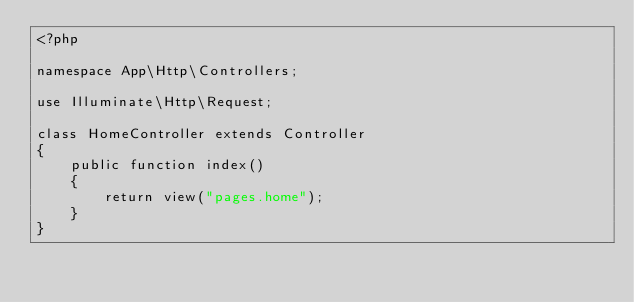<code> <loc_0><loc_0><loc_500><loc_500><_PHP_><?php

namespace App\Http\Controllers;

use Illuminate\Http\Request;

class HomeController extends Controller
{
    public function index()
    {
        return view("pages.home");
    }
}
</code> 